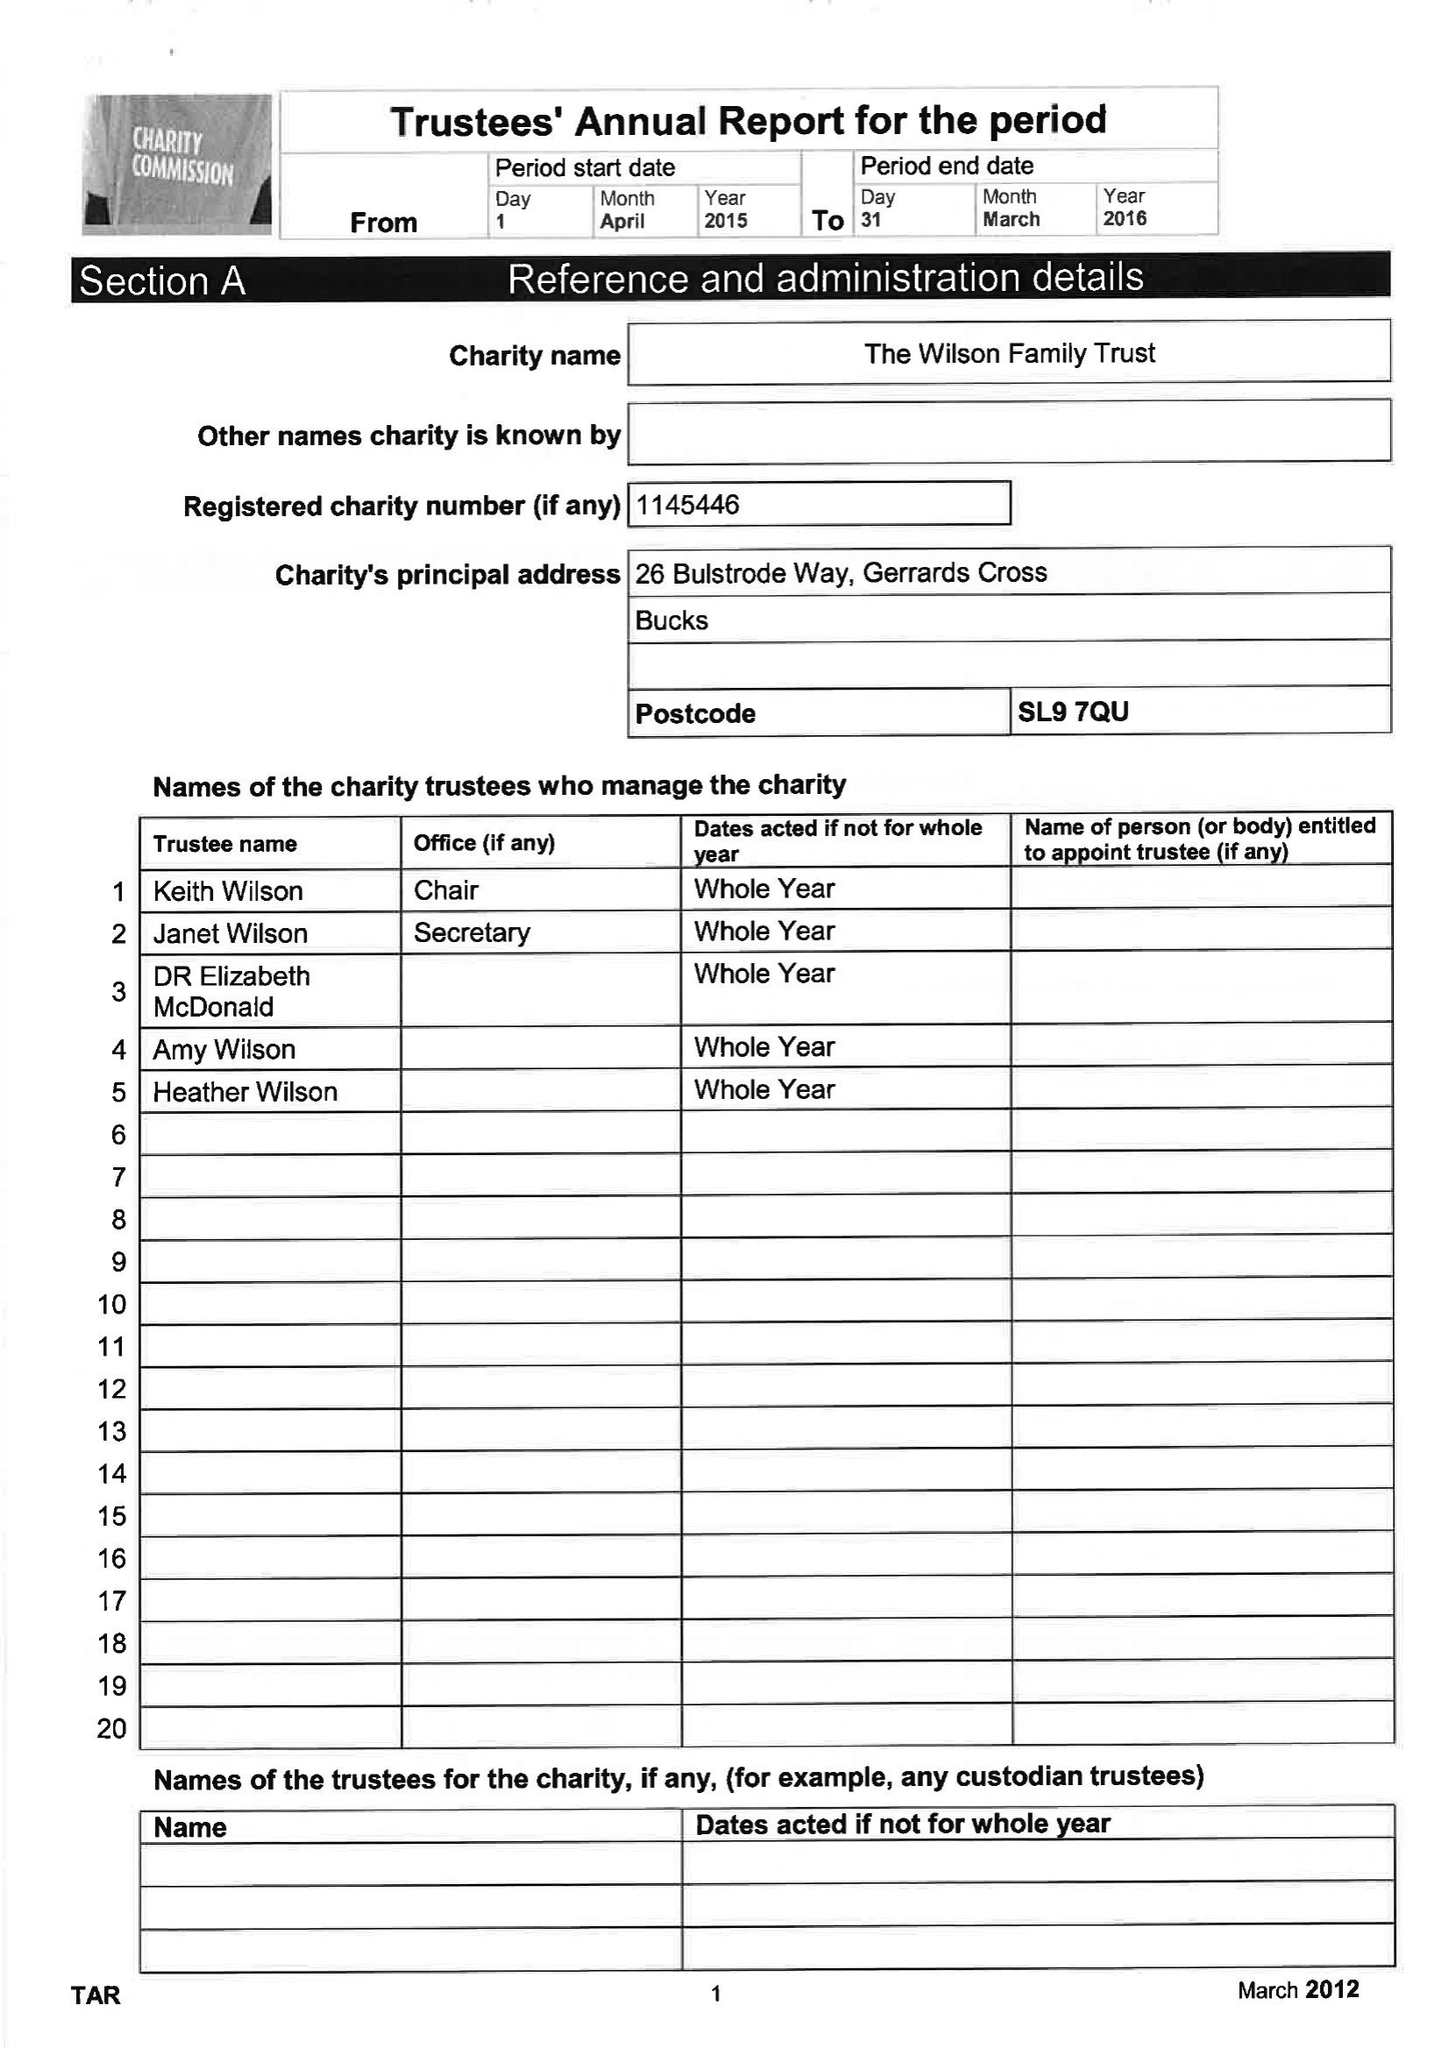What is the value for the address__street_line?
Answer the question using a single word or phrase. 26 BULSTRODE WAY 